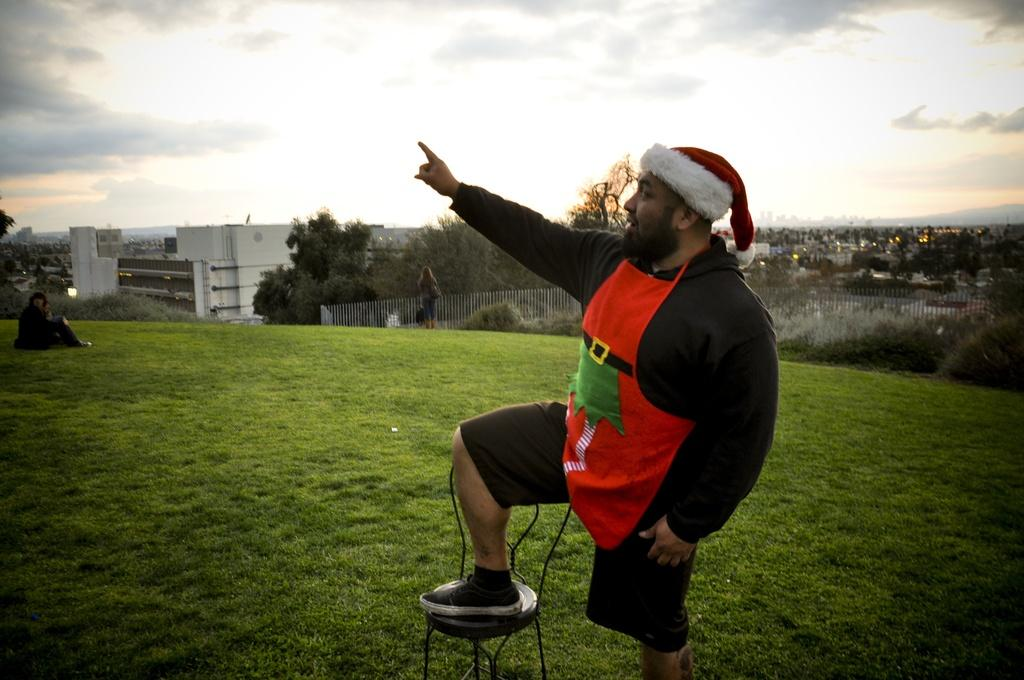What is the main subject of the image? There is a person in the image. How is the person positioned in the image? The person has their leg on a chair. What can be seen in the background of the image? There is a building, people, trees, and the sky visible in the background of the image. Can you tell me how many kittens are sitting on the person's lap in the image? There are no kittens present in the image; the person's leg is on a chair, and the background features a building, people, trees, and the sky. 